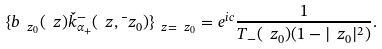<formula> <loc_0><loc_0><loc_500><loc_500>\{ b _ { \ z _ { 0 } } ( \ z ) \check { k } ^ { - } _ { \alpha _ { + } } ( \ z , \bar { \ } z _ { 0 } ) \} _ { \ z = \ z _ { 0 } } = e ^ { i c } \frac { 1 } { T _ { - } ( \ z _ { 0 } ) ( 1 - | \ z _ { 0 } | ^ { 2 } ) } .</formula> 